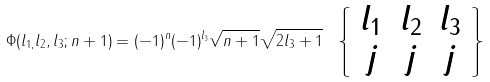<formula> <loc_0><loc_0><loc_500><loc_500>\Phi ( l _ { 1 , } l _ { 2 } , l _ { 3 } ; n + 1 ) = ( - 1 ) ^ { n } ( - 1 ) ^ { l _ { 3 } } \sqrt { n + 1 } \sqrt { 2 l _ { 3 } + 1 } \ \left \{ \begin{array} [ c ] { c c c } l _ { 1 } & l _ { 2 } & l _ { 3 } \\ j & j & j \end{array} \right \}</formula> 